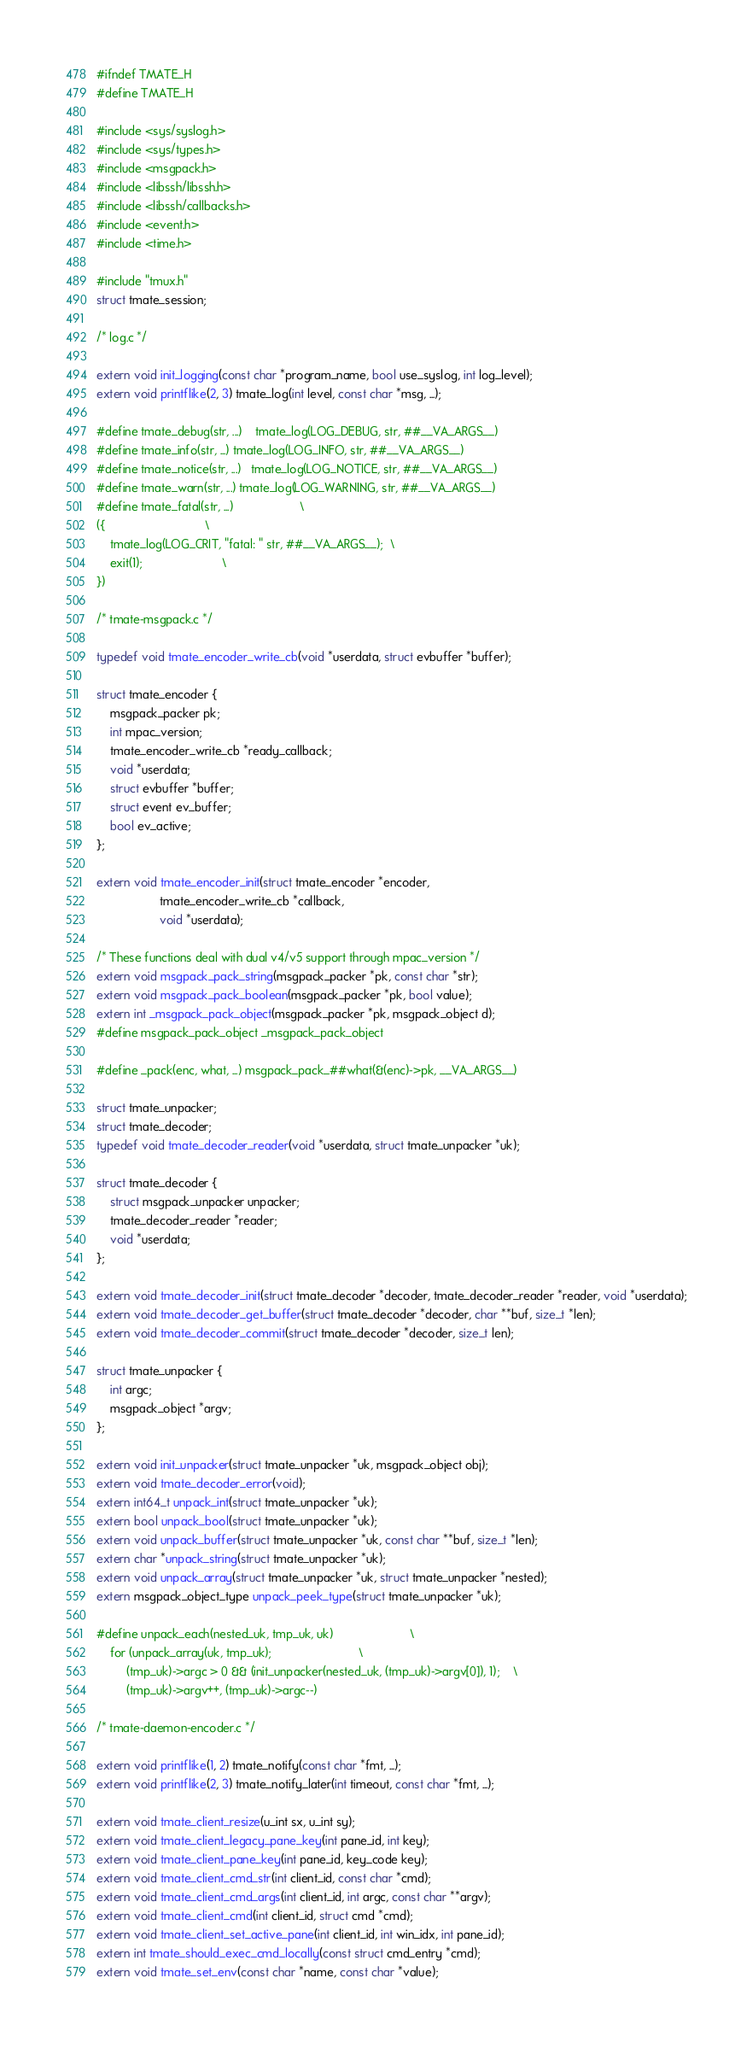Convert code to text. <code><loc_0><loc_0><loc_500><loc_500><_C_>#ifndef TMATE_H
#define TMATE_H

#include <sys/syslog.h>
#include <sys/types.h>
#include <msgpack.h>
#include <libssh/libssh.h>
#include <libssh/callbacks.h>
#include <event.h>
#include <time.h>

#include "tmux.h"
struct tmate_session;

/* log.c */

extern void init_logging(const char *program_name, bool use_syslog, int log_level);
extern void printflike(2, 3) tmate_log(int level, const char *msg, ...);

#define tmate_debug(str, ...)	tmate_log(LOG_DEBUG, str, ##__VA_ARGS__)
#define tmate_info(str, ...)	tmate_log(LOG_INFO, str, ##__VA_ARGS__)
#define tmate_notice(str, ...)	tmate_log(LOG_NOTICE, str, ##__VA_ARGS__)
#define tmate_warn(str, ...)	tmate_log(LOG_WARNING, str, ##__VA_ARGS__)
#define tmate_fatal(str, ...)					\
({								\
	tmate_log(LOG_CRIT, "fatal: " str, ##__VA_ARGS__);	\
 	exit(1);						\
})

/* tmate-msgpack.c */

typedef void tmate_encoder_write_cb(void *userdata, struct evbuffer *buffer);

struct tmate_encoder {
	msgpack_packer pk;
	int mpac_version;
	tmate_encoder_write_cb *ready_callback;
	void *userdata;
	struct evbuffer *buffer;
	struct event ev_buffer;
	bool ev_active;
};

extern void tmate_encoder_init(struct tmate_encoder *encoder,
			       tmate_encoder_write_cb *callback,
			       void *userdata);

/* These functions deal with dual v4/v5 support through mpac_version */
extern void msgpack_pack_string(msgpack_packer *pk, const char *str);
extern void msgpack_pack_boolean(msgpack_packer *pk, bool value);
extern int _msgpack_pack_object(msgpack_packer *pk, msgpack_object d);
#define msgpack_pack_object _msgpack_pack_object

#define _pack(enc, what, ...) msgpack_pack_##what(&(enc)->pk, __VA_ARGS__)

struct tmate_unpacker;
struct tmate_decoder;
typedef void tmate_decoder_reader(void *userdata, struct tmate_unpacker *uk);

struct tmate_decoder {
	struct msgpack_unpacker unpacker;
	tmate_decoder_reader *reader;
	void *userdata;
};

extern void tmate_decoder_init(struct tmate_decoder *decoder, tmate_decoder_reader *reader, void *userdata);
extern void tmate_decoder_get_buffer(struct tmate_decoder *decoder, char **buf, size_t *len);
extern void tmate_decoder_commit(struct tmate_decoder *decoder, size_t len);

struct tmate_unpacker {
	int argc;
	msgpack_object *argv;
};

extern void init_unpacker(struct tmate_unpacker *uk, msgpack_object obj);
extern void tmate_decoder_error(void);
extern int64_t unpack_int(struct tmate_unpacker *uk);
extern bool unpack_bool(struct tmate_unpacker *uk);
extern void unpack_buffer(struct tmate_unpacker *uk, const char **buf, size_t *len);
extern char *unpack_string(struct tmate_unpacker *uk);
extern void unpack_array(struct tmate_unpacker *uk, struct tmate_unpacker *nested);
extern msgpack_object_type unpack_peek_type(struct tmate_unpacker *uk);

#define unpack_each(nested_uk, tmp_uk, uk)						\
	for (unpack_array(uk, tmp_uk);							\
	     (tmp_uk)->argc > 0 && (init_unpacker(nested_uk, (tmp_uk)->argv[0]), 1);	\
	     (tmp_uk)->argv++, (tmp_uk)->argc--)

/* tmate-daemon-encoder.c */

extern void printflike(1, 2) tmate_notify(const char *fmt, ...);
extern void printflike(2, 3) tmate_notify_later(int timeout, const char *fmt, ...);

extern void tmate_client_resize(u_int sx, u_int sy);
extern void tmate_client_legacy_pane_key(int pane_id, int key);
extern void tmate_client_pane_key(int pane_id, key_code key);
extern void tmate_client_cmd_str(int client_id, const char *cmd);
extern void tmate_client_cmd_args(int client_id, int argc, const char **argv);
extern void tmate_client_cmd(int client_id, struct cmd *cmd);
extern void tmate_client_set_active_pane(int client_id, int win_idx, int pane_id);
extern int tmate_should_exec_cmd_locally(const struct cmd_entry *cmd);
extern void tmate_set_env(const char *name, const char *value);</code> 